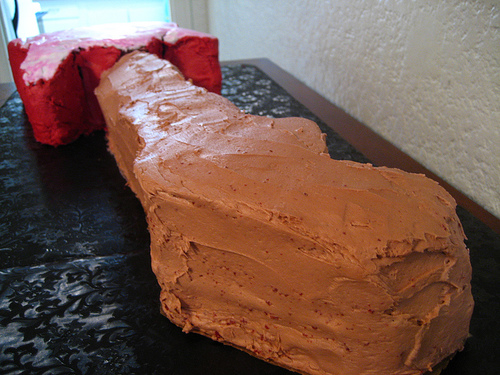<image>
Is the clay next to the mud? No. The clay is not positioned next to the mud. They are located in different areas of the scene. Is the cake in front of the wall? Yes. The cake is positioned in front of the wall, appearing closer to the camera viewpoint. 